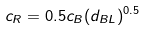<formula> <loc_0><loc_0><loc_500><loc_500>c _ { R } = 0 . 5 c _ { B } ( d _ { B L } ) ^ { 0 . 5 }</formula> 